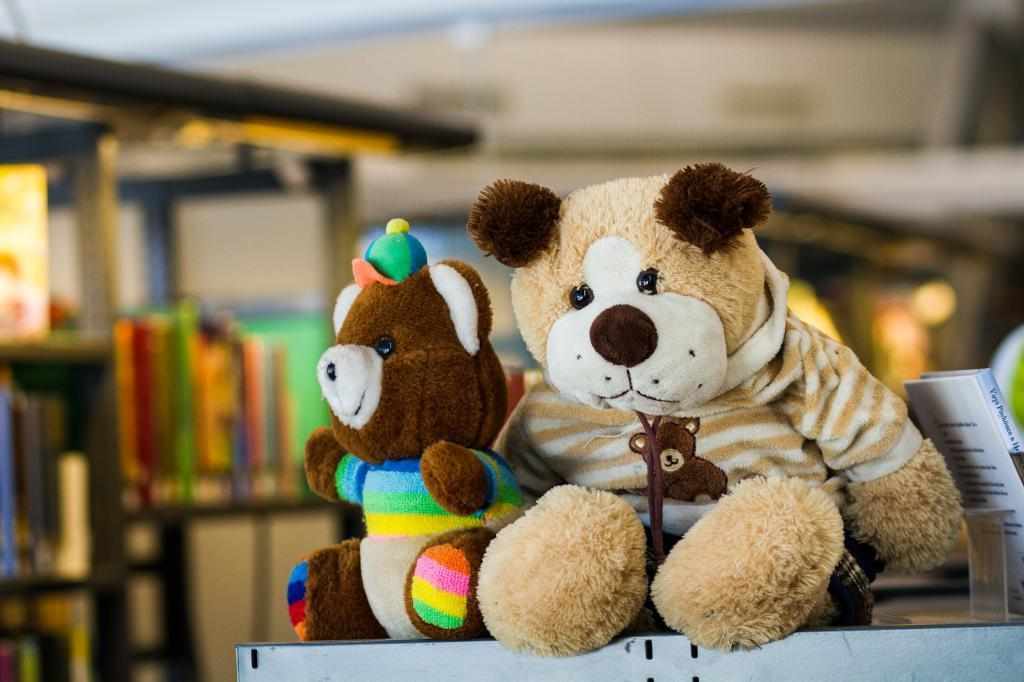What is the main subject in the center of the image? There are teddy bears in the center of the image. What can be seen on the left side of the image? There is a rack on the left side of the image. What type of ink is being used to color the teddy bears in the image? There is no ink present in the image, as the teddy bears are physical objects and not drawings or illustrations. 